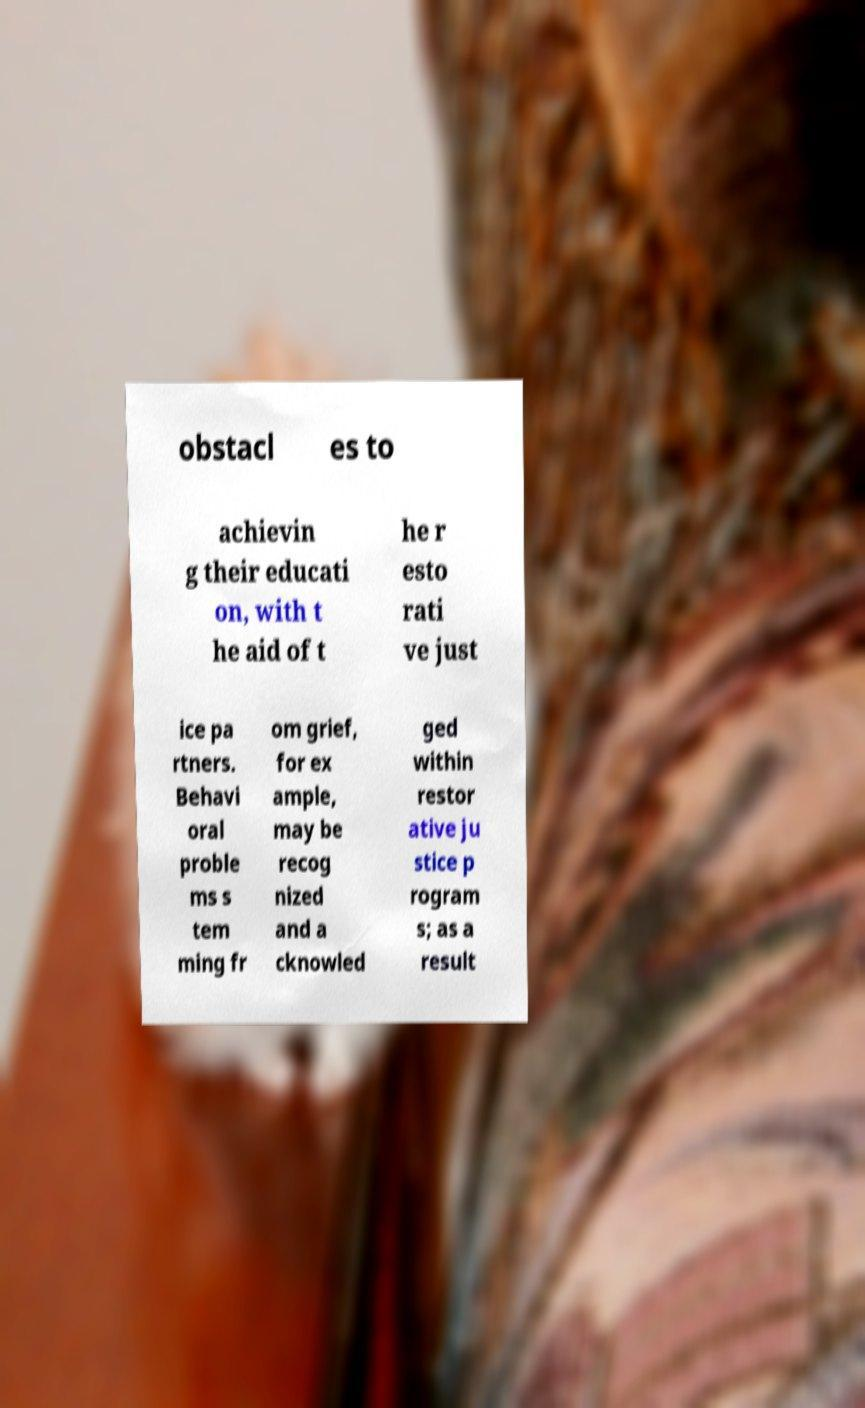For documentation purposes, I need the text within this image transcribed. Could you provide that? obstacl es to achievin g their educati on, with t he aid of t he r esto rati ve just ice pa rtners. Behavi oral proble ms s tem ming fr om grief, for ex ample, may be recog nized and a cknowled ged within restor ative ju stice p rogram s; as a result 